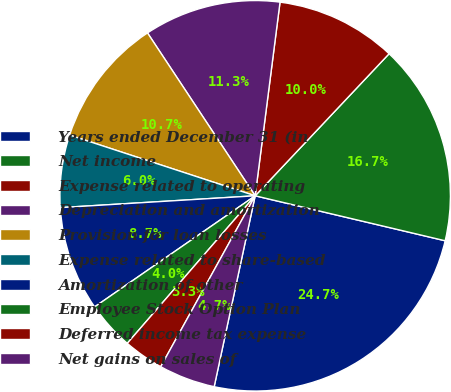<chart> <loc_0><loc_0><loc_500><loc_500><pie_chart><fcel>Years ended December 31 (in<fcel>Net income<fcel>Expense related to operating<fcel>Depreciation and amortization<fcel>Provision for loan losses<fcel>Expense related to share-based<fcel>Amortization of other<fcel>Employee Stock Option Plan<fcel>Deferred income tax expense<fcel>Net gains on sales of<nl><fcel>24.67%<fcel>16.67%<fcel>10.0%<fcel>11.33%<fcel>10.67%<fcel>6.0%<fcel>8.67%<fcel>4.0%<fcel>3.33%<fcel>4.67%<nl></chart> 